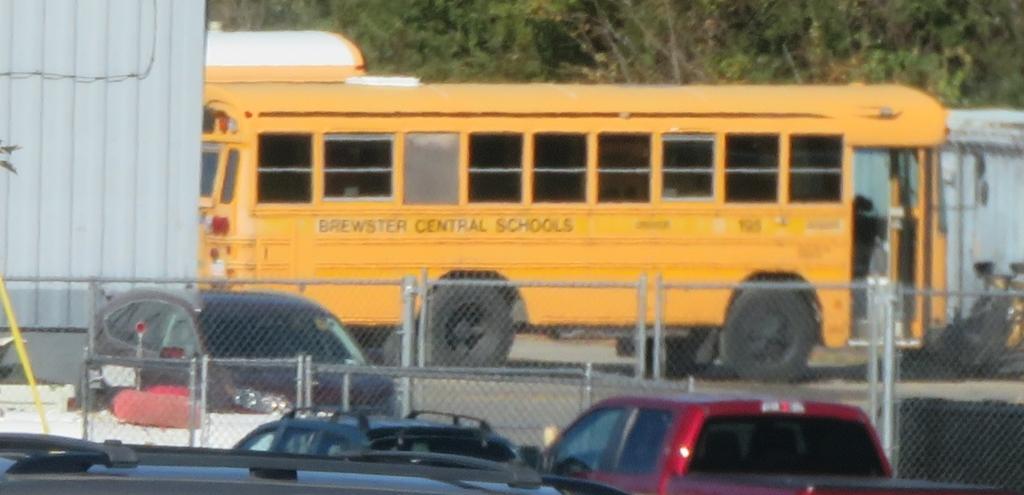How would you summarize this image in a sentence or two? In this picture I can see few cars and the fencing in front. In the middle of this picture I can see a school bus. In the background I can see the trees. 